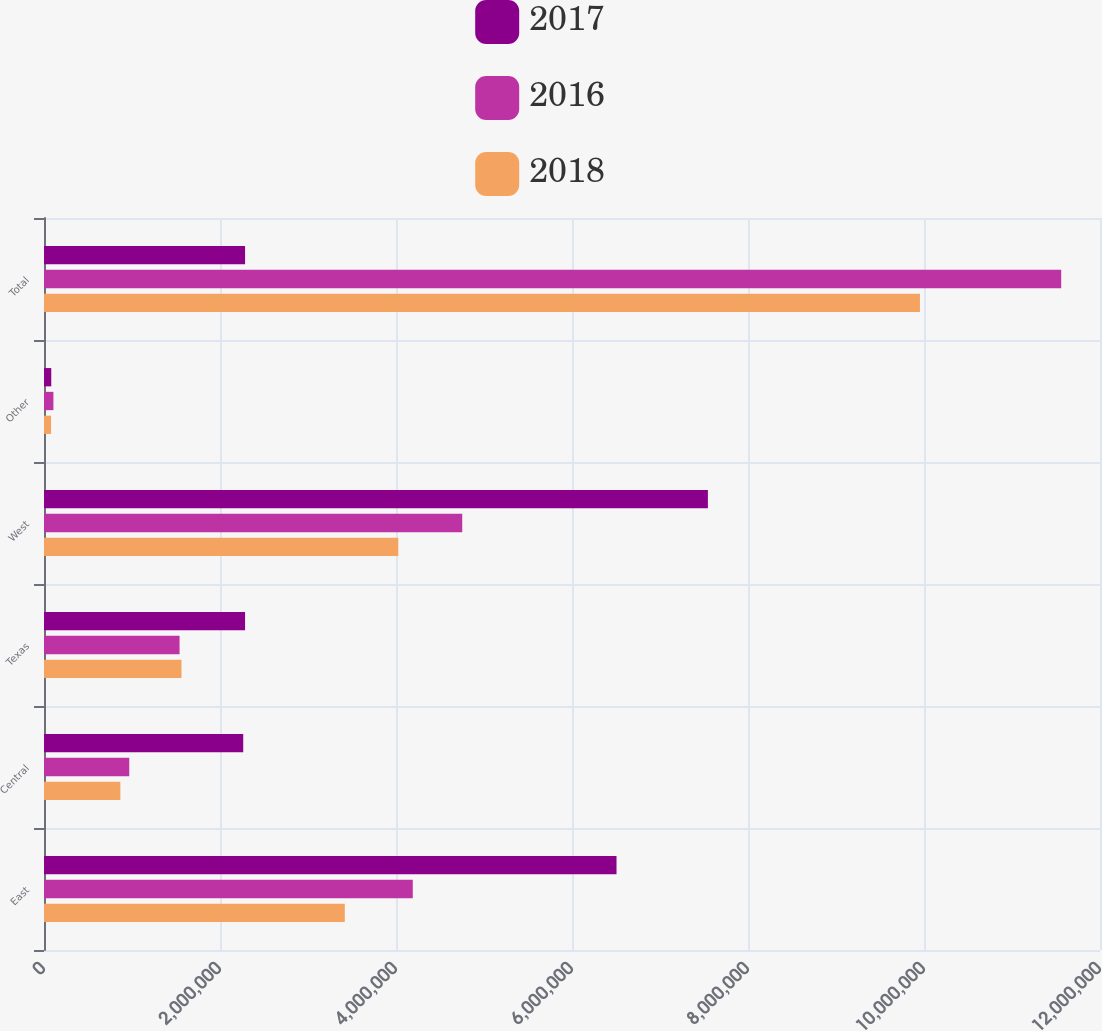<chart> <loc_0><loc_0><loc_500><loc_500><stacked_bar_chart><ecel><fcel>East<fcel>Central<fcel>Texas<fcel>West<fcel>Other<fcel>Total<nl><fcel>2017<fcel>6.50587e+06<fcel>2.26395e+06<fcel>2.28473e+06<fcel>7.54424e+06<fcel>82522<fcel>2.28473e+06<nl><fcel>2016<fcel>4.19065e+06<fcel>968771<fcel>1.54042e+06<fcel>4.75266e+06<fcel>106741<fcel>1.15592e+07<nl><fcel>2018<fcel>3.41786e+06<fcel>867632<fcel>1.56251e+06<fcel>4.02572e+06<fcel>80214<fcel>9.95394e+06<nl></chart> 